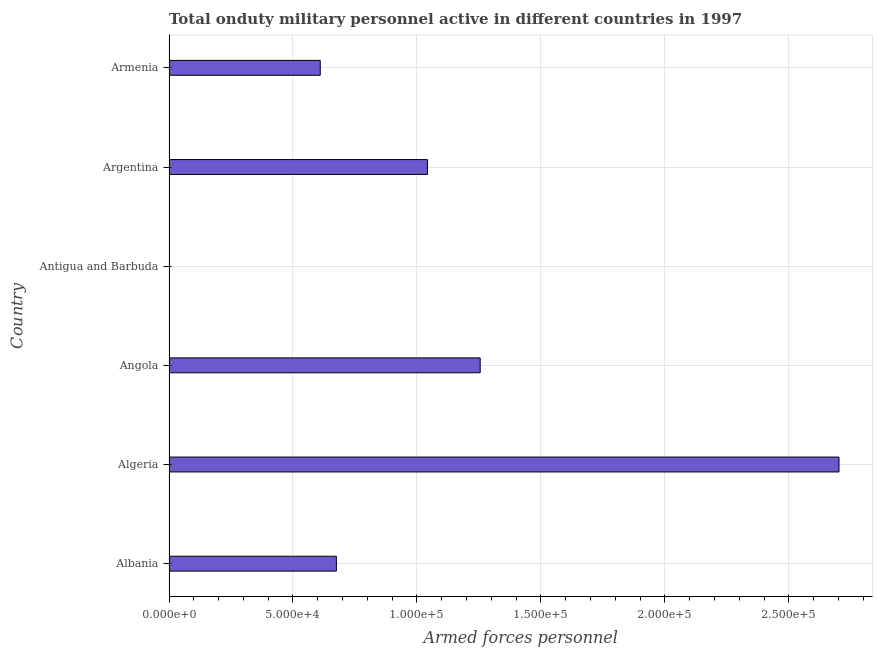Does the graph contain any zero values?
Your answer should be very brief. No. Does the graph contain grids?
Provide a short and direct response. Yes. What is the title of the graph?
Provide a succinct answer. Total onduty military personnel active in different countries in 1997. What is the label or title of the X-axis?
Keep it short and to the point. Armed forces personnel. What is the label or title of the Y-axis?
Provide a short and direct response. Country. What is the number of armed forces personnel in Albania?
Your answer should be very brief. 6.75e+04. Across all countries, what is the maximum number of armed forces personnel?
Provide a succinct answer. 2.70e+05. Across all countries, what is the minimum number of armed forces personnel?
Provide a succinct answer. 150. In which country was the number of armed forces personnel maximum?
Offer a very short reply. Algeria. In which country was the number of armed forces personnel minimum?
Provide a short and direct response. Antigua and Barbuda. What is the sum of the number of armed forces personnel?
Your response must be concise. 6.29e+05. What is the difference between the number of armed forces personnel in Algeria and Armenia?
Keep it short and to the point. 2.09e+05. What is the average number of armed forces personnel per country?
Keep it short and to the point. 1.05e+05. What is the median number of armed forces personnel?
Make the answer very short. 8.59e+04. What is the ratio of the number of armed forces personnel in Algeria to that in Argentina?
Your answer should be very brief. 2.59. Is the number of armed forces personnel in Albania less than that in Antigua and Barbuda?
Your answer should be compact. No. What is the difference between the highest and the second highest number of armed forces personnel?
Offer a very short reply. 1.45e+05. Is the sum of the number of armed forces personnel in Albania and Armenia greater than the maximum number of armed forces personnel across all countries?
Provide a short and direct response. No. What is the difference between the highest and the lowest number of armed forces personnel?
Give a very brief answer. 2.70e+05. In how many countries, is the number of armed forces personnel greater than the average number of armed forces personnel taken over all countries?
Provide a succinct answer. 2. How many bars are there?
Your answer should be very brief. 6. How many countries are there in the graph?
Give a very brief answer. 6. Are the values on the major ticks of X-axis written in scientific E-notation?
Ensure brevity in your answer.  Yes. What is the Armed forces personnel of Albania?
Your answer should be very brief. 6.75e+04. What is the Armed forces personnel in Algeria?
Offer a very short reply. 2.70e+05. What is the Armed forces personnel in Angola?
Make the answer very short. 1.26e+05. What is the Armed forces personnel in Antigua and Barbuda?
Your answer should be very brief. 150. What is the Armed forces personnel in Argentina?
Your answer should be compact. 1.04e+05. What is the Armed forces personnel of Armenia?
Keep it short and to the point. 6.10e+04. What is the difference between the Armed forces personnel in Albania and Algeria?
Your answer should be very brief. -2.03e+05. What is the difference between the Armed forces personnel in Albania and Angola?
Your answer should be very brief. -5.80e+04. What is the difference between the Armed forces personnel in Albania and Antigua and Barbuda?
Keep it short and to the point. 6.74e+04. What is the difference between the Armed forces personnel in Albania and Argentina?
Your answer should be compact. -3.67e+04. What is the difference between the Armed forces personnel in Albania and Armenia?
Your response must be concise. 6500. What is the difference between the Armed forces personnel in Algeria and Angola?
Make the answer very short. 1.45e+05. What is the difference between the Armed forces personnel in Algeria and Antigua and Barbuda?
Your answer should be compact. 2.70e+05. What is the difference between the Armed forces personnel in Algeria and Argentina?
Ensure brevity in your answer.  1.66e+05. What is the difference between the Armed forces personnel in Algeria and Armenia?
Provide a short and direct response. 2.09e+05. What is the difference between the Armed forces personnel in Angola and Antigua and Barbuda?
Offer a terse response. 1.25e+05. What is the difference between the Armed forces personnel in Angola and Argentina?
Keep it short and to the point. 2.13e+04. What is the difference between the Armed forces personnel in Angola and Armenia?
Your response must be concise. 6.45e+04. What is the difference between the Armed forces personnel in Antigua and Barbuda and Argentina?
Offer a terse response. -1.04e+05. What is the difference between the Armed forces personnel in Antigua and Barbuda and Armenia?
Offer a terse response. -6.08e+04. What is the difference between the Armed forces personnel in Argentina and Armenia?
Give a very brief answer. 4.32e+04. What is the ratio of the Armed forces personnel in Albania to that in Algeria?
Keep it short and to the point. 0.25. What is the ratio of the Armed forces personnel in Albania to that in Angola?
Keep it short and to the point. 0.54. What is the ratio of the Armed forces personnel in Albania to that in Antigua and Barbuda?
Your answer should be very brief. 450. What is the ratio of the Armed forces personnel in Albania to that in Argentina?
Keep it short and to the point. 0.65. What is the ratio of the Armed forces personnel in Albania to that in Armenia?
Your answer should be very brief. 1.11. What is the ratio of the Armed forces personnel in Algeria to that in Angola?
Keep it short and to the point. 2.15. What is the ratio of the Armed forces personnel in Algeria to that in Antigua and Barbuda?
Your answer should be very brief. 1801.33. What is the ratio of the Armed forces personnel in Algeria to that in Argentina?
Give a very brief answer. 2.59. What is the ratio of the Armed forces personnel in Algeria to that in Armenia?
Ensure brevity in your answer.  4.43. What is the ratio of the Armed forces personnel in Angola to that in Antigua and Barbuda?
Your answer should be compact. 836.67. What is the ratio of the Armed forces personnel in Angola to that in Argentina?
Offer a terse response. 1.2. What is the ratio of the Armed forces personnel in Angola to that in Armenia?
Ensure brevity in your answer.  2.06. What is the ratio of the Armed forces personnel in Antigua and Barbuda to that in Argentina?
Provide a succinct answer. 0. What is the ratio of the Armed forces personnel in Antigua and Barbuda to that in Armenia?
Provide a short and direct response. 0. What is the ratio of the Armed forces personnel in Argentina to that in Armenia?
Make the answer very short. 1.71. 